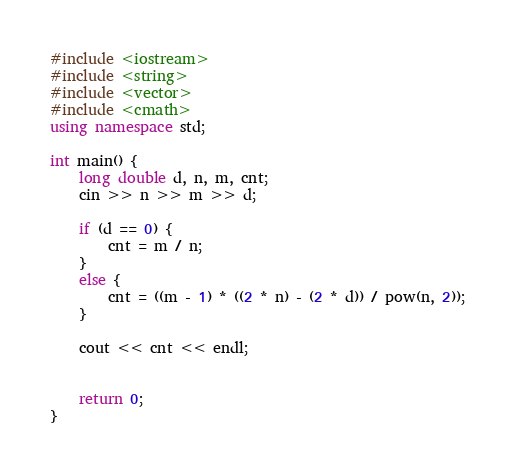<code> <loc_0><loc_0><loc_500><loc_500><_C++_>#include <iostream>
#include <string>
#include <vector>
#include <cmath>
using namespace std;

int main() {
	long double d, n, m, cnt;
	cin >> n >> m >> d;

	if (d == 0) {
		cnt = m / n;
	}
	else {
		cnt = ((m - 1) * ((2 * n) - (2 * d)) / pow(n, 2));
	}

	cout << cnt << endl;


	return 0;
}</code> 